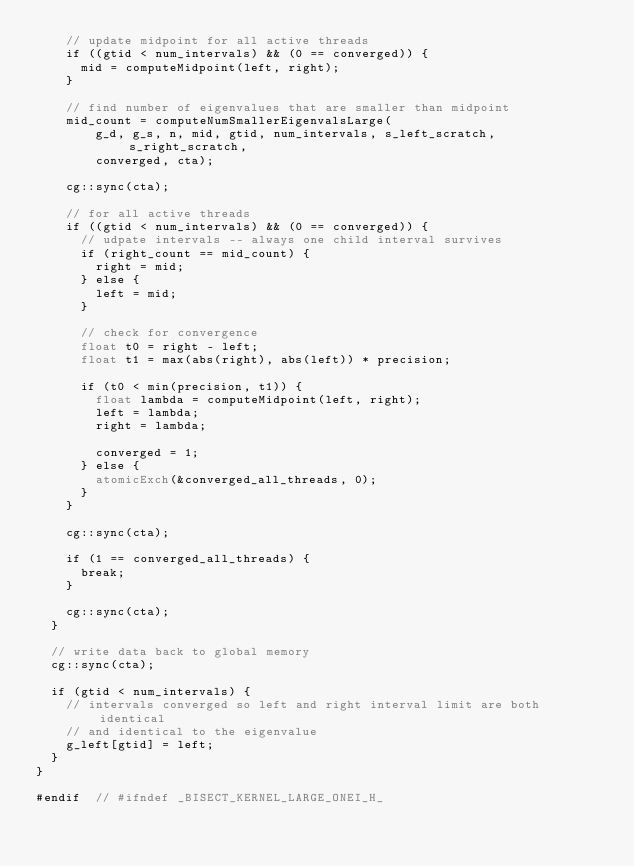Convert code to text. <code><loc_0><loc_0><loc_500><loc_500><_Cuda_>    // update midpoint for all active threads
    if ((gtid < num_intervals) && (0 == converged)) {
      mid = computeMidpoint(left, right);
    }

    // find number of eigenvalues that are smaller than midpoint
    mid_count = computeNumSmallerEigenvalsLarge(
        g_d, g_s, n, mid, gtid, num_intervals, s_left_scratch, s_right_scratch,
        converged, cta);

    cg::sync(cta);

    // for all active threads
    if ((gtid < num_intervals) && (0 == converged)) {
      // udpate intervals -- always one child interval survives
      if (right_count == mid_count) {
        right = mid;
      } else {
        left = mid;
      }

      // check for convergence
      float t0 = right - left;
      float t1 = max(abs(right), abs(left)) * precision;

      if (t0 < min(precision, t1)) {
        float lambda = computeMidpoint(left, right);
        left = lambda;
        right = lambda;

        converged = 1;
      } else {
        atomicExch(&converged_all_threads, 0);
      }
    }

    cg::sync(cta);

    if (1 == converged_all_threads) {
      break;
    }

    cg::sync(cta);
  }

  // write data back to global memory
  cg::sync(cta);

  if (gtid < num_intervals) {
    // intervals converged so left and right interval limit are both identical
    // and identical to the eigenvalue
    g_left[gtid] = left;
  }
}

#endif  // #ifndef _BISECT_KERNEL_LARGE_ONEI_H_
</code> 